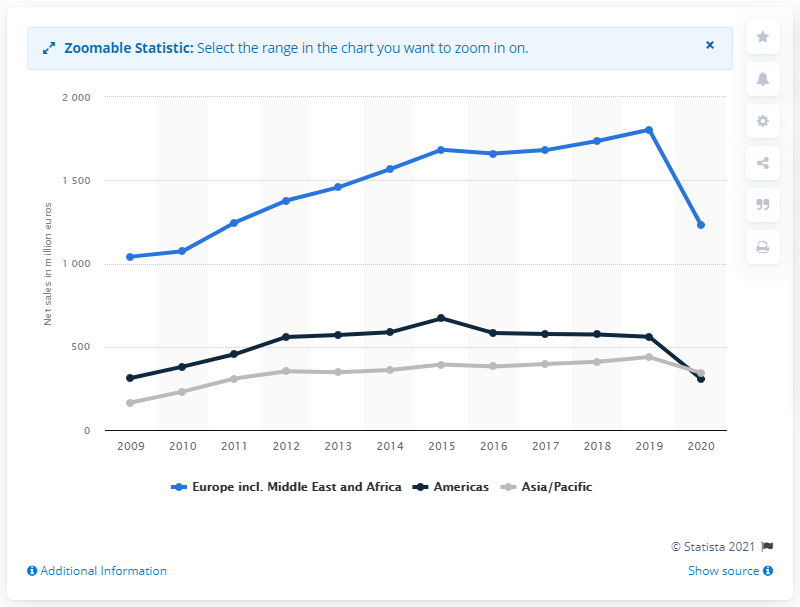Indicate a few pertinent items in this graphic. In 2020, Hugo Boss' net sales in the Americas were approximately 308 million dollars. 